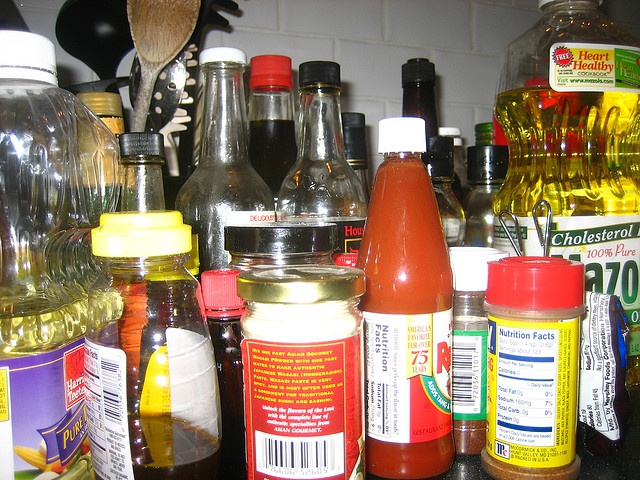Describe the objects in this image and their specific colors. I can see bottle in black, white, gray, and yellow tones, bottle in black, olive, maroon, and ivory tones, bottle in black, gray, olive, and white tones, bottle in black, white, red, and brown tones, and bottle in black, white, salmon, and red tones in this image. 